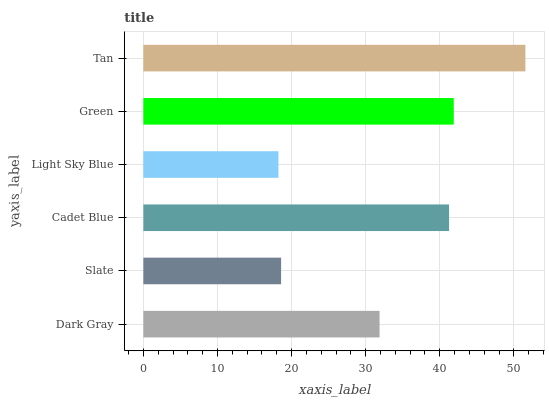Is Light Sky Blue the minimum?
Answer yes or no. Yes. Is Tan the maximum?
Answer yes or no. Yes. Is Slate the minimum?
Answer yes or no. No. Is Slate the maximum?
Answer yes or no. No. Is Dark Gray greater than Slate?
Answer yes or no. Yes. Is Slate less than Dark Gray?
Answer yes or no. Yes. Is Slate greater than Dark Gray?
Answer yes or no. No. Is Dark Gray less than Slate?
Answer yes or no. No. Is Cadet Blue the high median?
Answer yes or no. Yes. Is Dark Gray the low median?
Answer yes or no. Yes. Is Green the high median?
Answer yes or no. No. Is Light Sky Blue the low median?
Answer yes or no. No. 